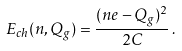Convert formula to latex. <formula><loc_0><loc_0><loc_500><loc_500>E _ { c h } ( n , Q _ { g } ) = \frac { ( n e - Q _ { g } ) ^ { 2 } } { 2 C } \, .</formula> 